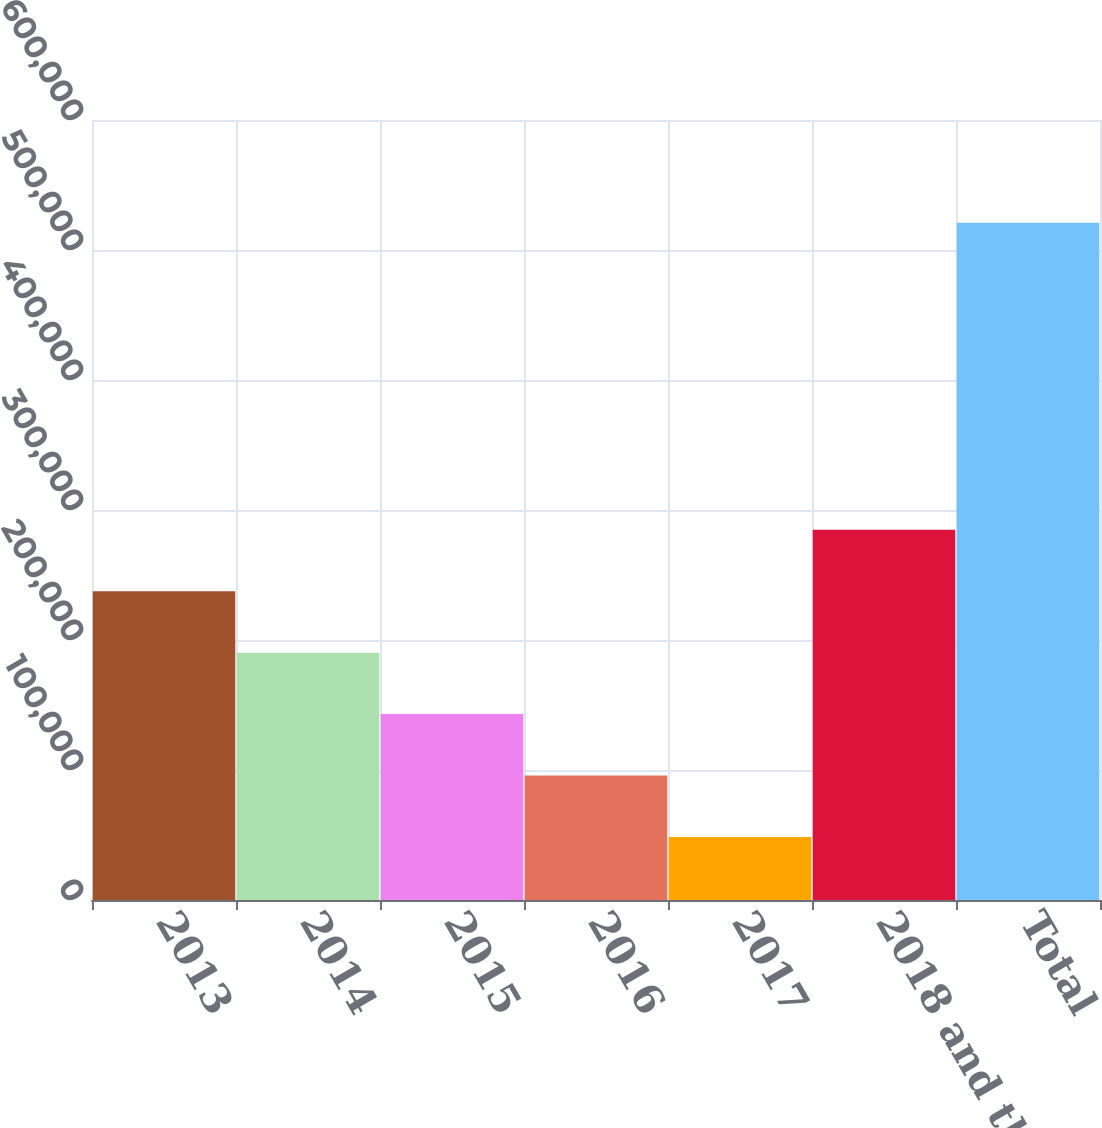<chart> <loc_0><loc_0><loc_500><loc_500><bar_chart><fcel>2013<fcel>2014<fcel>2015<fcel>2016<fcel>2017<fcel>2018 and thereafter<fcel>Total<nl><fcel>237485<fcel>190243<fcel>143001<fcel>95759.7<fcel>48518<fcel>284726<fcel>520935<nl></chart> 